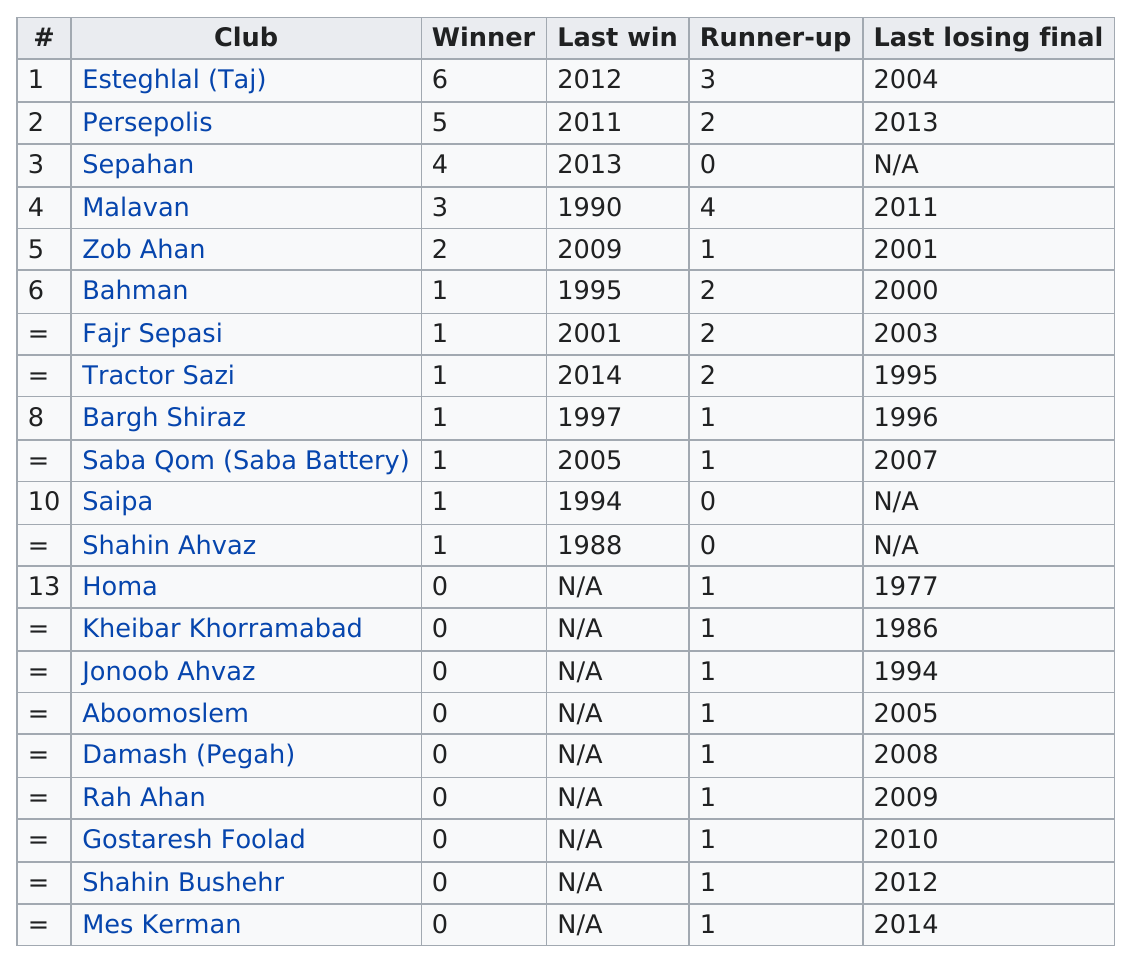Mention a couple of crucial points in this snapshot. I declare that Malavan has three wins, and not Homa. Esteghlal (Taj)" is the top winner of clubs, according to records. Esteghlal (Taj) has the largest number of championships among all clubs. The number of clubs that have won at least two matches is 5. In 1994, SAIPA won the championship, and in the following year, Bahman won the championship. 